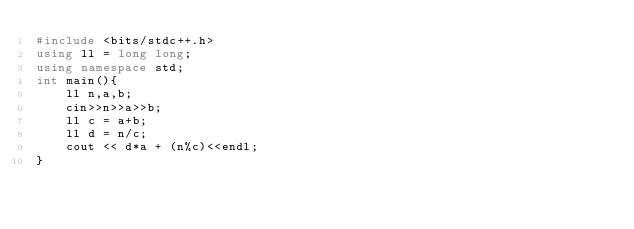<code> <loc_0><loc_0><loc_500><loc_500><_C++_>#include <bits/stdc++.h>
using ll = long long;
using namespace std;
int main(){
    ll n,a,b;
    cin>>n>>a>>b;
    ll c = a+b;
    ll d = n/c;
    cout << d*a + (n%c)<<endl;
}</code> 